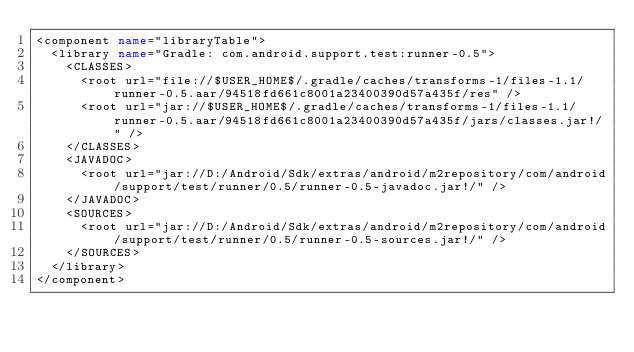Convert code to text. <code><loc_0><loc_0><loc_500><loc_500><_XML_><component name="libraryTable">
  <library name="Gradle: com.android.support.test:runner-0.5">
    <CLASSES>
      <root url="file://$USER_HOME$/.gradle/caches/transforms-1/files-1.1/runner-0.5.aar/94518fd661c8001a23400390d57a435f/res" />
      <root url="jar://$USER_HOME$/.gradle/caches/transforms-1/files-1.1/runner-0.5.aar/94518fd661c8001a23400390d57a435f/jars/classes.jar!/" />
    </CLASSES>
    <JAVADOC>
      <root url="jar://D:/Android/Sdk/extras/android/m2repository/com/android/support/test/runner/0.5/runner-0.5-javadoc.jar!/" />
    </JAVADOC>
    <SOURCES>
      <root url="jar://D:/Android/Sdk/extras/android/m2repository/com/android/support/test/runner/0.5/runner-0.5-sources.jar!/" />
    </SOURCES>
  </library>
</component></code> 